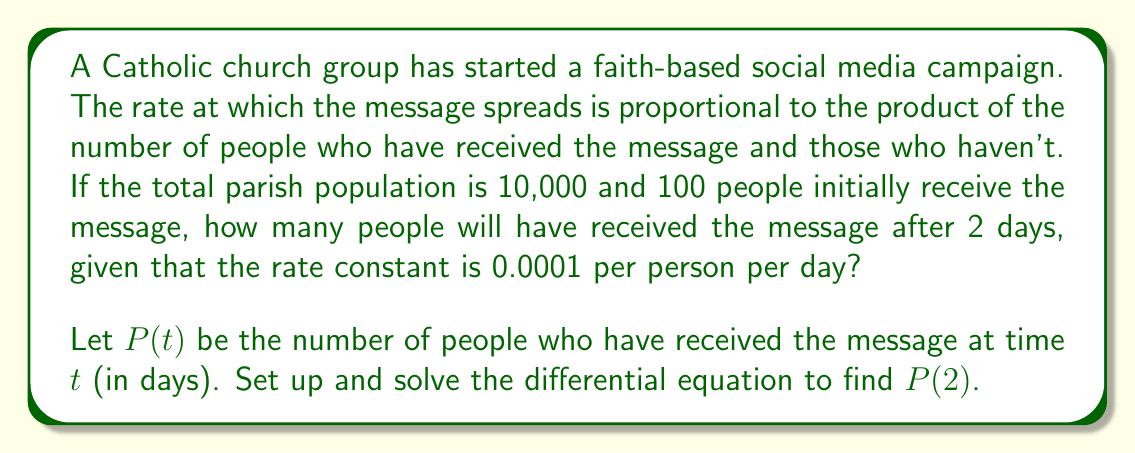Solve this math problem. Let's approach this step-by-step:

1) The differential equation for this logistic growth model is:

   $$\frac{dP}{dt} = kP(N-P)$$

   where $k$ is the rate constant, $N$ is the total population, and $P$ is the number of people who have received the message.

2) Given:
   $N = 10,000$
   $k = 0.0001$
   $P(0) = 100$ (initial condition)

3) Substituting these values into the differential equation:

   $$\frac{dP}{dt} = 0.0001P(10000-P)$$

4) This is a separable differential equation. Rearranging:

   $$\frac{dP}{P(10000-P)} = 0.0001dt$$

5) Integrating both sides:

   $$\int \frac{dP}{P(10000-P)} = \int 0.0001dt$$

6) The left side integrates to:

   $$\frac{1}{10000}\ln\left|\frac{P}{10000-P}\right| = 0.0001t + C$$

7) Using the initial condition $P(0) = 100$ to solve for $C$:

   $$\frac{1}{10000}\ln\left|\frac{100}{9900}\right| = C$$

8) Substituting this back and simplifying:

   $$\ln\left|\frac{P}{10000-P}\right| - \ln\left|\frac{100}{9900}\right| = t$$

9) Solving for $P$:

   $$P = \frac{10000}{1 + 99e^{-t}}$$

10) To find $P(2)$, we substitute $t=2$:

    $$P(2) = \frac{10000}{1 + 99e^{-2}} \approx 726.69$$
Answer: After 2 days, approximately 727 people will have received the message. 